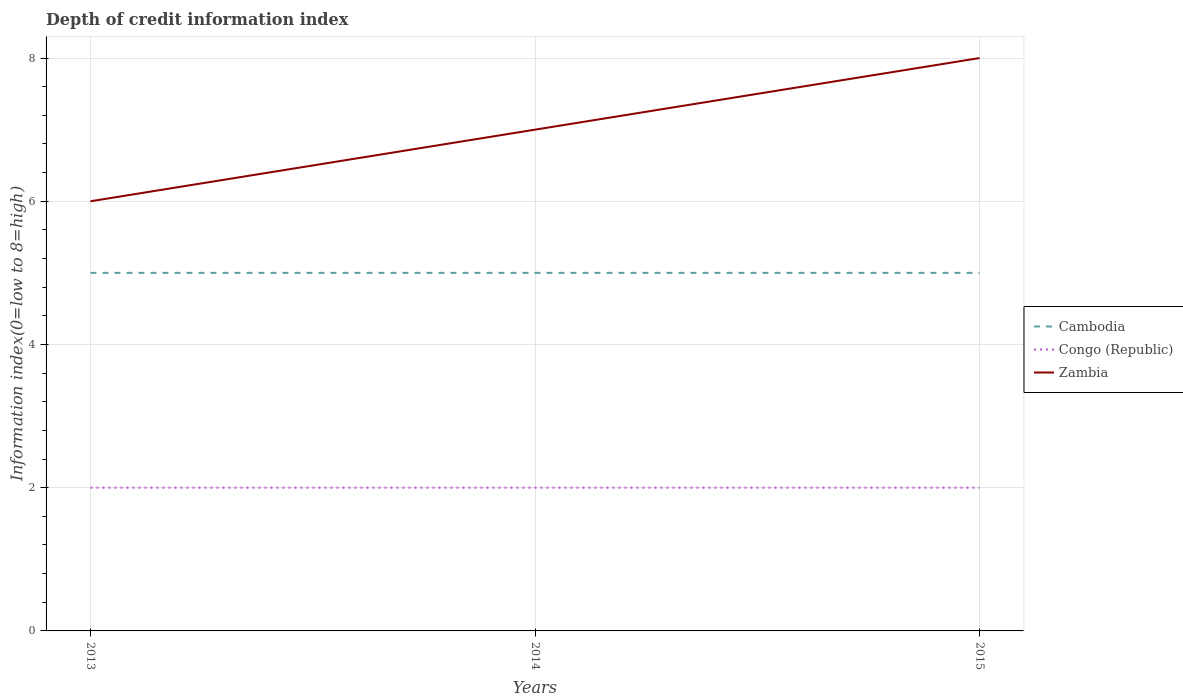How many different coloured lines are there?
Offer a very short reply. 3. Does the line corresponding to Congo (Republic) intersect with the line corresponding to Zambia?
Your response must be concise. No. Is the number of lines equal to the number of legend labels?
Your answer should be compact. Yes. Across all years, what is the maximum information index in Cambodia?
Keep it short and to the point. 5. In which year was the information index in Congo (Republic) maximum?
Keep it short and to the point. 2013. What is the difference between the highest and the second highest information index in Cambodia?
Provide a short and direct response. 0. How many years are there in the graph?
Ensure brevity in your answer.  3. What is the difference between two consecutive major ticks on the Y-axis?
Keep it short and to the point. 2. Does the graph contain grids?
Provide a short and direct response. Yes. Where does the legend appear in the graph?
Your response must be concise. Center right. What is the title of the graph?
Your answer should be compact. Depth of credit information index. What is the label or title of the Y-axis?
Offer a terse response. Information index(0=low to 8=high). What is the Information index(0=low to 8=high) of Congo (Republic) in 2013?
Your answer should be compact. 2. What is the Information index(0=low to 8=high) of Zambia in 2013?
Your response must be concise. 6. What is the Information index(0=low to 8=high) of Cambodia in 2014?
Offer a very short reply. 5. What is the Information index(0=low to 8=high) of Congo (Republic) in 2014?
Make the answer very short. 2. What is the Information index(0=low to 8=high) in Zambia in 2014?
Keep it short and to the point. 7. What is the Information index(0=low to 8=high) in Cambodia in 2015?
Provide a succinct answer. 5. What is the Information index(0=low to 8=high) of Congo (Republic) in 2015?
Your answer should be compact. 2. Across all years, what is the maximum Information index(0=low to 8=high) in Cambodia?
Give a very brief answer. 5. Across all years, what is the maximum Information index(0=low to 8=high) of Congo (Republic)?
Your response must be concise. 2. Across all years, what is the maximum Information index(0=low to 8=high) of Zambia?
Your answer should be compact. 8. Across all years, what is the minimum Information index(0=low to 8=high) in Cambodia?
Give a very brief answer. 5. Across all years, what is the minimum Information index(0=low to 8=high) of Zambia?
Keep it short and to the point. 6. What is the difference between the Information index(0=low to 8=high) in Cambodia in 2013 and that in 2014?
Give a very brief answer. 0. What is the difference between the Information index(0=low to 8=high) in Cambodia in 2013 and that in 2015?
Offer a terse response. 0. What is the difference between the Information index(0=low to 8=high) in Congo (Republic) in 2013 and that in 2015?
Offer a very short reply. 0. What is the difference between the Information index(0=low to 8=high) in Zambia in 2013 and that in 2015?
Provide a short and direct response. -2. What is the difference between the Information index(0=low to 8=high) in Cambodia in 2014 and that in 2015?
Ensure brevity in your answer.  0. What is the difference between the Information index(0=low to 8=high) in Zambia in 2014 and that in 2015?
Make the answer very short. -1. What is the difference between the Information index(0=low to 8=high) of Cambodia in 2013 and the Information index(0=low to 8=high) of Congo (Republic) in 2014?
Give a very brief answer. 3. What is the difference between the Information index(0=low to 8=high) of Congo (Republic) in 2013 and the Information index(0=low to 8=high) of Zambia in 2014?
Your answer should be very brief. -5. What is the difference between the Information index(0=low to 8=high) of Cambodia in 2013 and the Information index(0=low to 8=high) of Zambia in 2015?
Your response must be concise. -3. What is the difference between the Information index(0=low to 8=high) of Cambodia in 2014 and the Information index(0=low to 8=high) of Congo (Republic) in 2015?
Your response must be concise. 3. In the year 2013, what is the difference between the Information index(0=low to 8=high) of Cambodia and Information index(0=low to 8=high) of Congo (Republic)?
Offer a very short reply. 3. In the year 2013, what is the difference between the Information index(0=low to 8=high) of Cambodia and Information index(0=low to 8=high) of Zambia?
Give a very brief answer. -1. In the year 2013, what is the difference between the Information index(0=low to 8=high) of Congo (Republic) and Information index(0=low to 8=high) of Zambia?
Your response must be concise. -4. In the year 2014, what is the difference between the Information index(0=low to 8=high) of Cambodia and Information index(0=low to 8=high) of Zambia?
Your response must be concise. -2. In the year 2014, what is the difference between the Information index(0=low to 8=high) of Congo (Republic) and Information index(0=low to 8=high) of Zambia?
Your response must be concise. -5. What is the ratio of the Information index(0=low to 8=high) of Congo (Republic) in 2013 to that in 2014?
Your response must be concise. 1. What is the ratio of the Information index(0=low to 8=high) of Zambia in 2013 to that in 2014?
Provide a short and direct response. 0.86. What is the ratio of the Information index(0=low to 8=high) of Congo (Republic) in 2013 to that in 2015?
Give a very brief answer. 1. What is the ratio of the Information index(0=low to 8=high) of Zambia in 2013 to that in 2015?
Offer a very short reply. 0.75. What is the ratio of the Information index(0=low to 8=high) of Congo (Republic) in 2014 to that in 2015?
Ensure brevity in your answer.  1. What is the ratio of the Information index(0=low to 8=high) in Zambia in 2014 to that in 2015?
Provide a short and direct response. 0.88. What is the difference between the highest and the second highest Information index(0=low to 8=high) in Cambodia?
Provide a succinct answer. 0. What is the difference between the highest and the second highest Information index(0=low to 8=high) in Congo (Republic)?
Give a very brief answer. 0. What is the difference between the highest and the second highest Information index(0=low to 8=high) of Zambia?
Your answer should be very brief. 1. What is the difference between the highest and the lowest Information index(0=low to 8=high) of Cambodia?
Offer a terse response. 0. What is the difference between the highest and the lowest Information index(0=low to 8=high) of Congo (Republic)?
Offer a terse response. 0. What is the difference between the highest and the lowest Information index(0=low to 8=high) of Zambia?
Your answer should be very brief. 2. 